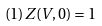Convert formula to latex. <formula><loc_0><loc_0><loc_500><loc_500>( 1 ) Z ( V , 0 ) = 1</formula> 